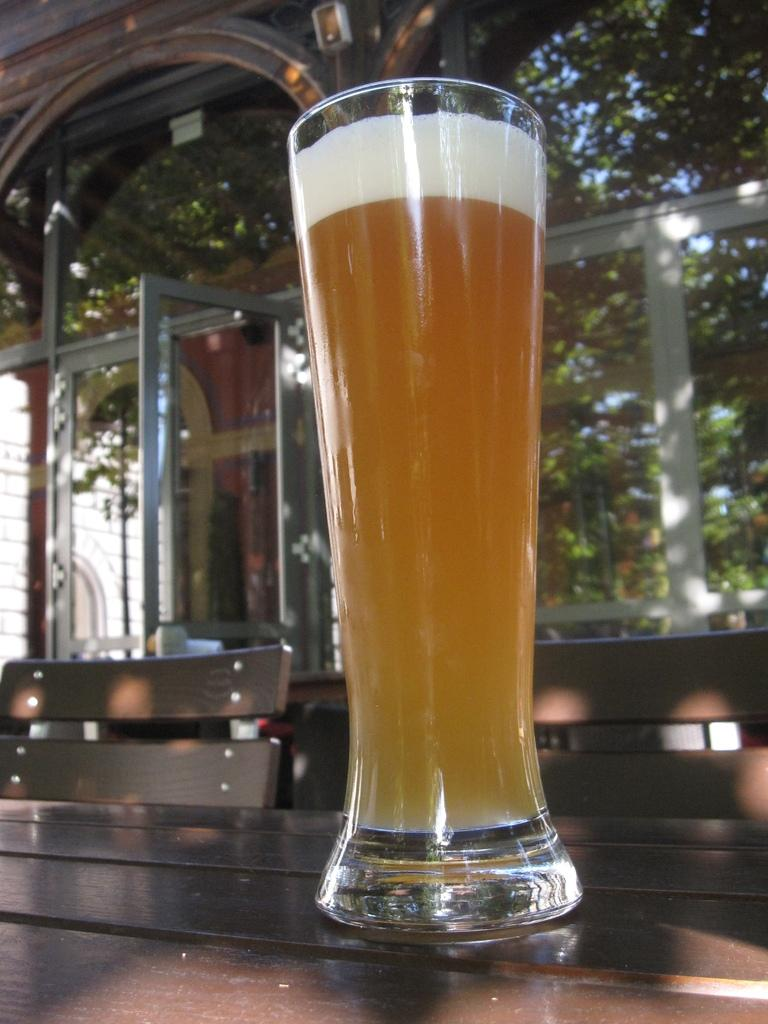What is on the table in the image? There is a glass on the table. What type of seating is visible in the image? There are benches in the image. What can be seen in the background of the image? There are glass windows in the background of the image. What type of potato is being protested in the image? There is no potato or protest present in the image. 